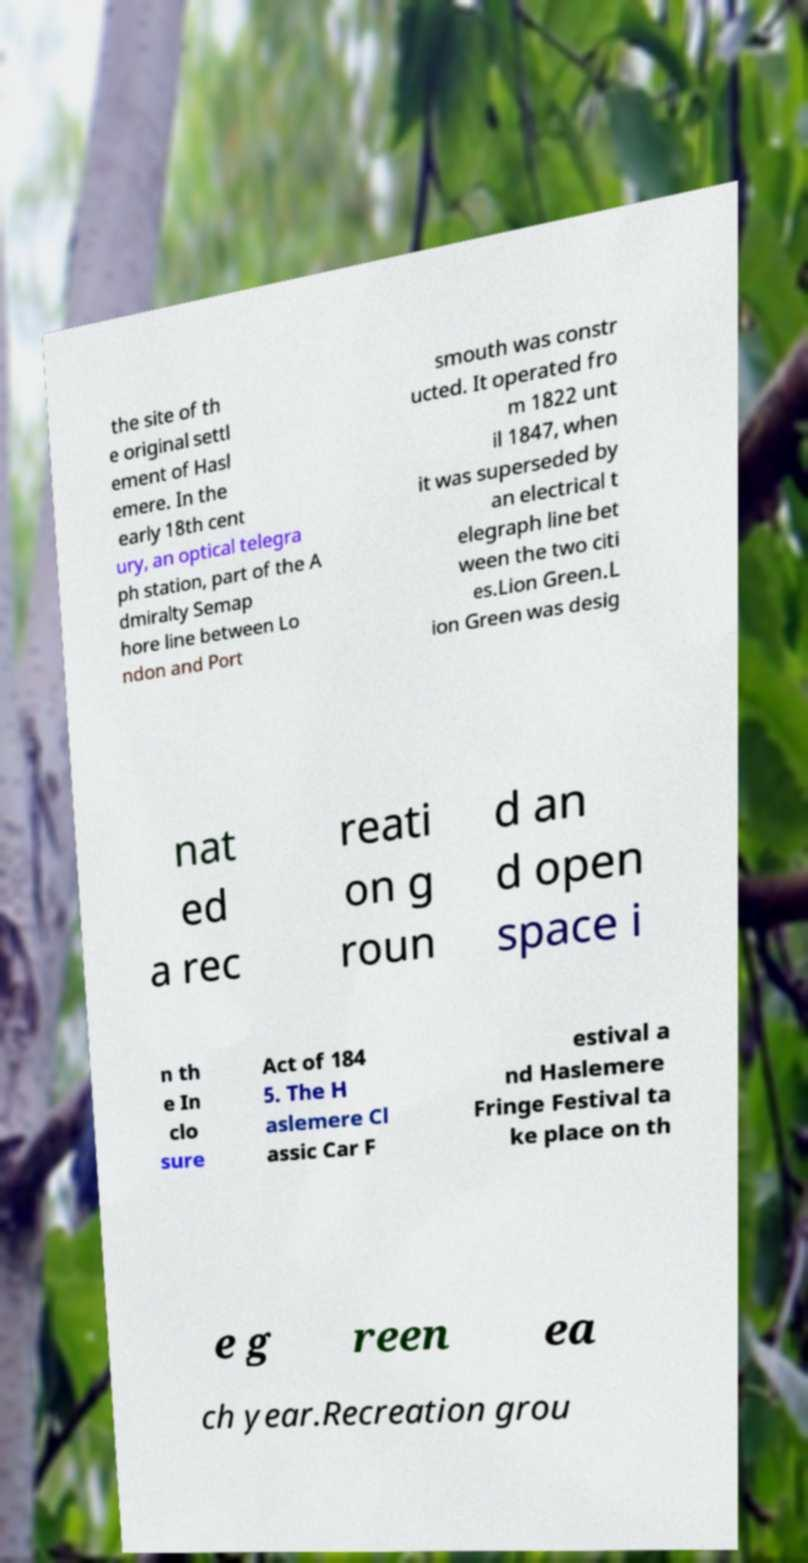For documentation purposes, I need the text within this image transcribed. Could you provide that? the site of th e original settl ement of Hasl emere. In the early 18th cent ury, an optical telegra ph station, part of the A dmiralty Semap hore line between Lo ndon and Port smouth was constr ucted. It operated fro m 1822 unt il 1847, when it was superseded by an electrical t elegraph line bet ween the two citi es.Lion Green.L ion Green was desig nat ed a rec reati on g roun d an d open space i n th e In clo sure Act of 184 5. The H aslemere Cl assic Car F estival a nd Haslemere Fringe Festival ta ke place on th e g reen ea ch year.Recreation grou 